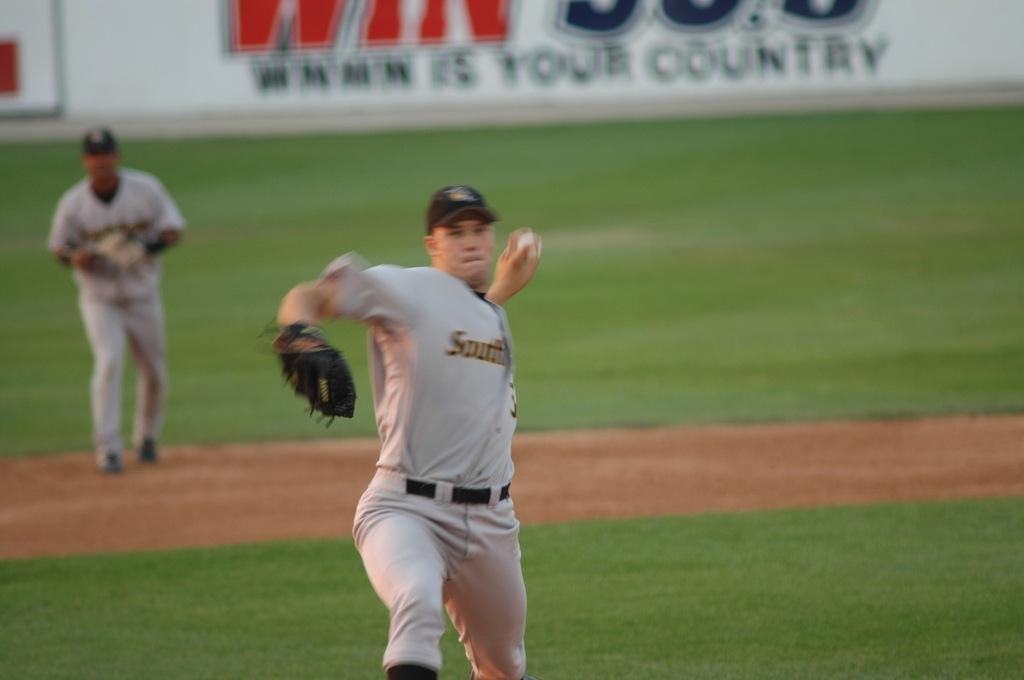<image>
Relay a brief, clear account of the picture shown. South reads the team name of the pitcher on the mound. 